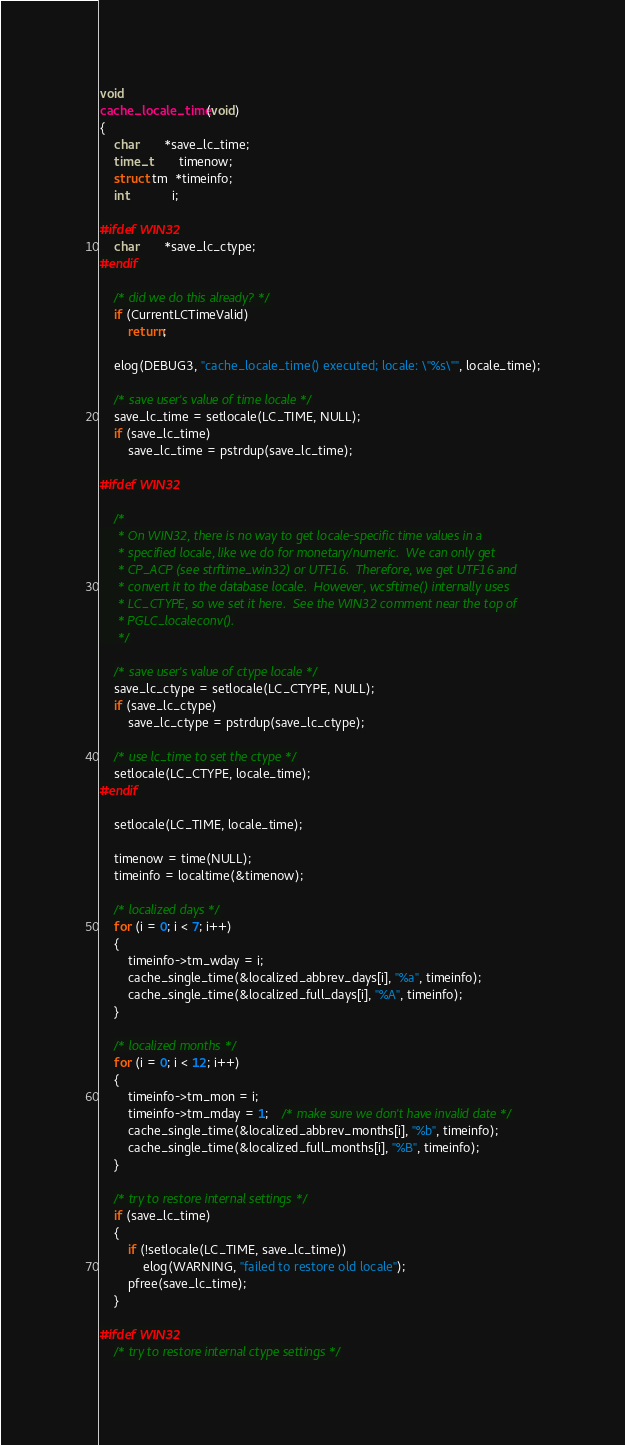Convert code to text. <code><loc_0><loc_0><loc_500><loc_500><_C_>void
cache_locale_time(void)
{
	char	   *save_lc_time;
	time_t		timenow;
	struct tm  *timeinfo;
	int			i;

#ifdef WIN32
	char	   *save_lc_ctype;
#endif

	/* did we do this already? */
	if (CurrentLCTimeValid)
		return;

	elog(DEBUG3, "cache_locale_time() executed; locale: \"%s\"", locale_time);

	/* save user's value of time locale */
	save_lc_time = setlocale(LC_TIME, NULL);
	if (save_lc_time)
		save_lc_time = pstrdup(save_lc_time);

#ifdef WIN32

	/*
	 * On WIN32, there is no way to get locale-specific time values in a
	 * specified locale, like we do for monetary/numeric.  We can only get
	 * CP_ACP (see strftime_win32) or UTF16.  Therefore, we get UTF16 and
	 * convert it to the database locale.  However, wcsftime() internally uses
	 * LC_CTYPE, so we set it here.  See the WIN32 comment near the top of
	 * PGLC_localeconv().
	 */

	/* save user's value of ctype locale */
	save_lc_ctype = setlocale(LC_CTYPE, NULL);
	if (save_lc_ctype)
		save_lc_ctype = pstrdup(save_lc_ctype);

	/* use lc_time to set the ctype */
	setlocale(LC_CTYPE, locale_time);
#endif

	setlocale(LC_TIME, locale_time);

	timenow = time(NULL);
	timeinfo = localtime(&timenow);

	/* localized days */
	for (i = 0; i < 7; i++)
	{
		timeinfo->tm_wday = i;
		cache_single_time(&localized_abbrev_days[i], "%a", timeinfo);
		cache_single_time(&localized_full_days[i], "%A", timeinfo);
	}

	/* localized months */
	for (i = 0; i < 12; i++)
	{
		timeinfo->tm_mon = i;
		timeinfo->tm_mday = 1;	/* make sure we don't have invalid date */
		cache_single_time(&localized_abbrev_months[i], "%b", timeinfo);
		cache_single_time(&localized_full_months[i], "%B", timeinfo);
	}

	/* try to restore internal settings */
	if (save_lc_time)
	{
		if (!setlocale(LC_TIME, save_lc_time))
			elog(WARNING, "failed to restore old locale");
		pfree(save_lc_time);
	}

#ifdef WIN32
	/* try to restore internal ctype settings */</code> 